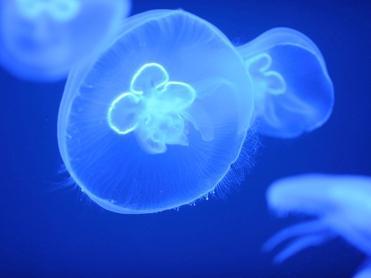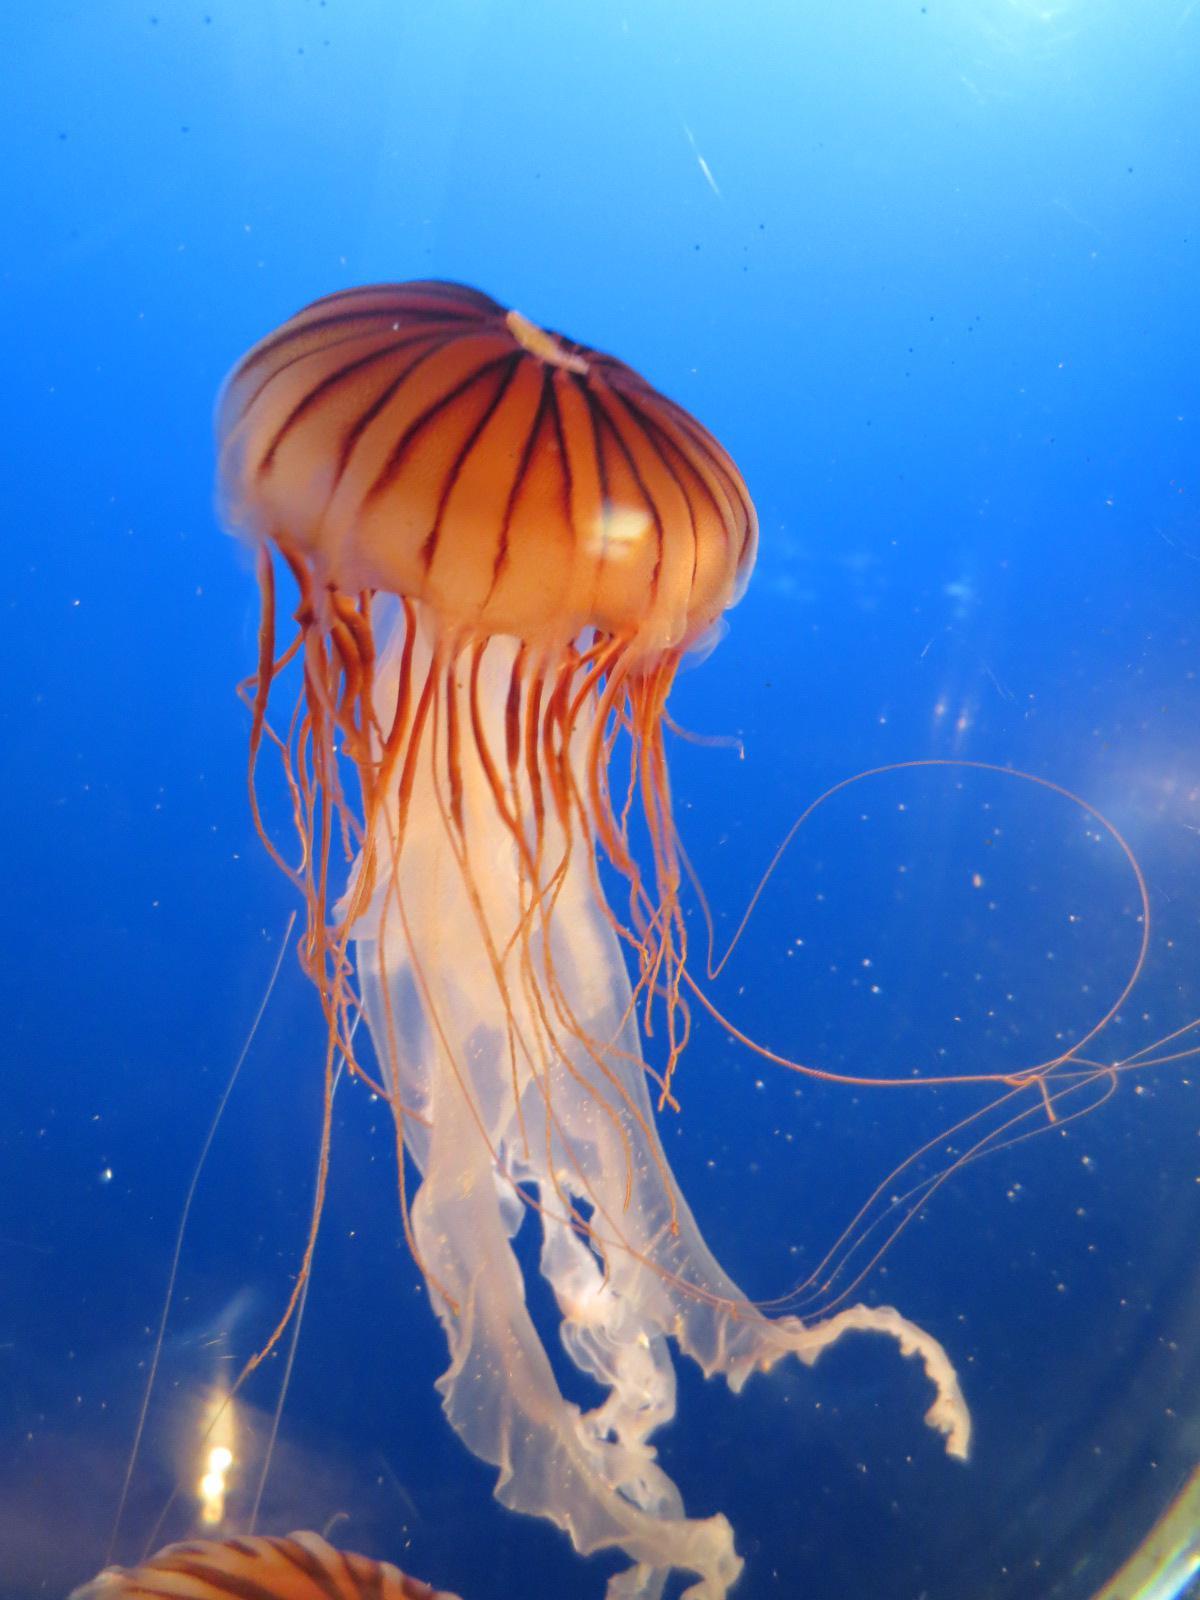The first image is the image on the left, the second image is the image on the right. Evaluate the accuracy of this statement regarding the images: "there are two jellyfish in the image pair". Is it true? Answer yes or no. No. The first image is the image on the left, the second image is the image on the right. Analyze the images presented: Is the assertion "One jellyfish has long tentacles." valid? Answer yes or no. Yes. 